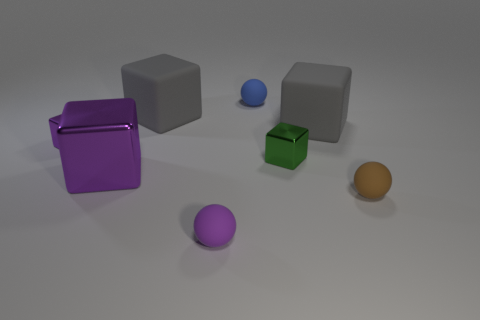Are there any tiny purple objects right of the small purple thing that is in front of the rubber sphere that is right of the blue matte ball?
Provide a succinct answer. No. What color is the object behind the gray matte block on the left side of the metallic thing right of the tiny blue rubber object?
Your response must be concise. Blue. What material is the other purple object that is the same shape as the large purple metallic object?
Ensure brevity in your answer.  Metal. There is a gray matte cube to the left of the small block on the right side of the large purple metallic block; how big is it?
Give a very brief answer. Large. There is a gray thing on the right side of the small green shiny thing; what material is it?
Offer a very short reply. Rubber. There is a blue thing that is the same material as the small purple sphere; what is its size?
Ensure brevity in your answer.  Small. How many other objects are the same shape as the brown rubber thing?
Your response must be concise. 2. There is a big metal thing; is it the same shape as the tiny green metallic object that is behind the large purple metallic thing?
Your response must be concise. Yes. What is the shape of the small rubber thing that is the same color as the large metallic thing?
Your answer should be very brief. Sphere. Are there any cylinders that have the same material as the green object?
Offer a terse response. No. 